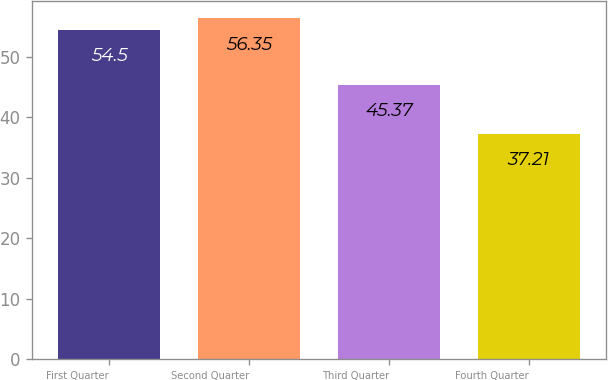<chart> <loc_0><loc_0><loc_500><loc_500><bar_chart><fcel>First Quarter<fcel>Second Quarter<fcel>Third Quarter<fcel>Fourth Quarter<nl><fcel>54.5<fcel>56.35<fcel>45.37<fcel>37.21<nl></chart> 